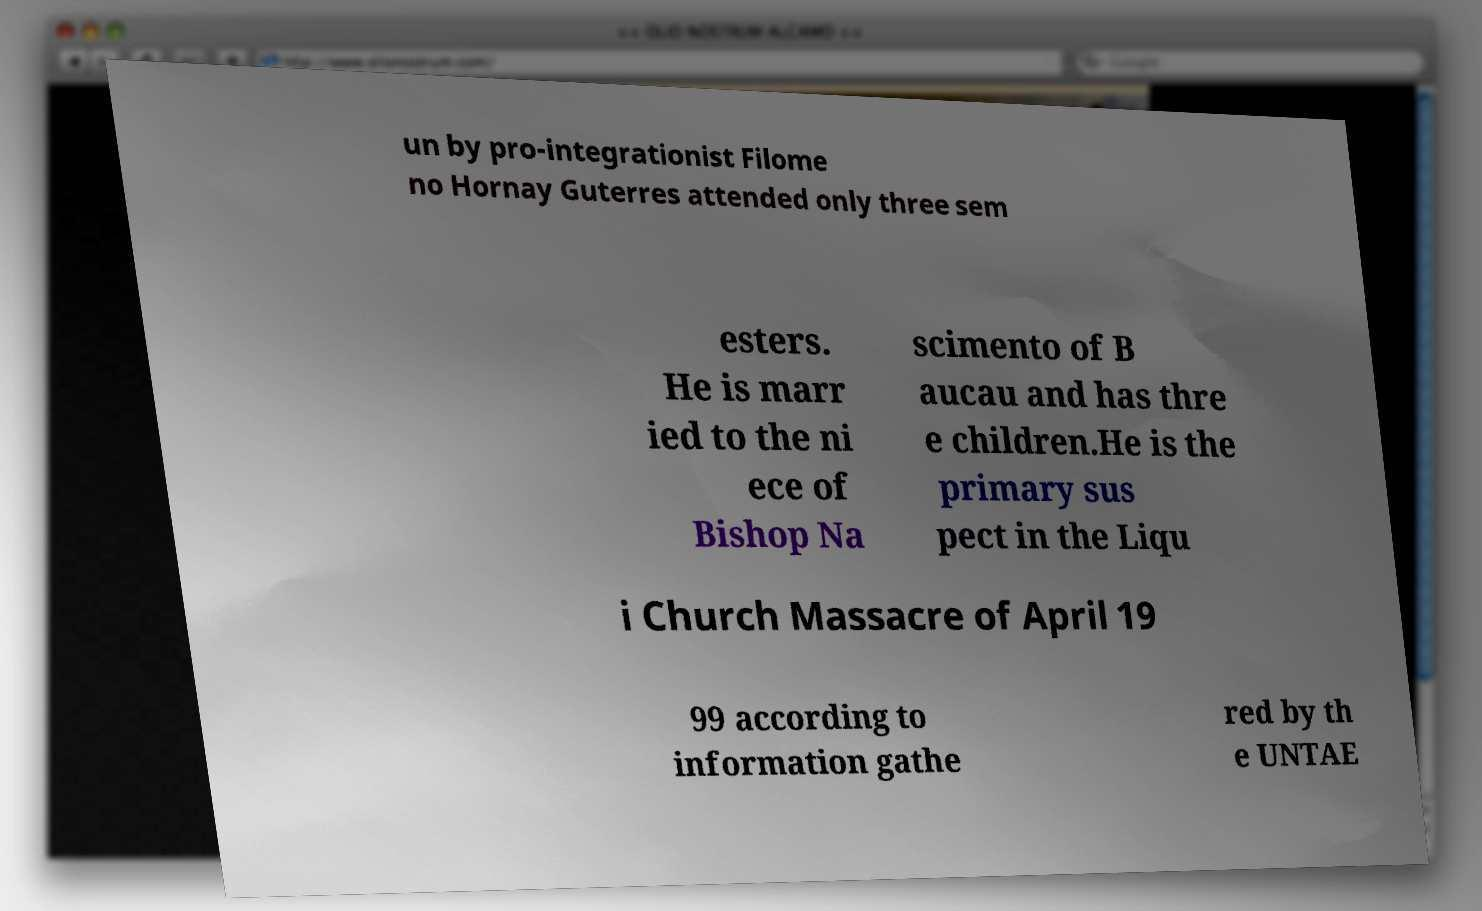For documentation purposes, I need the text within this image transcribed. Could you provide that? un by pro-integrationist Filome no Hornay Guterres attended only three sem esters. He is marr ied to the ni ece of Bishop Na scimento of B aucau and has thre e children.He is the primary sus pect in the Liqu i Church Massacre of April 19 99 according to information gathe red by th e UNTAE 